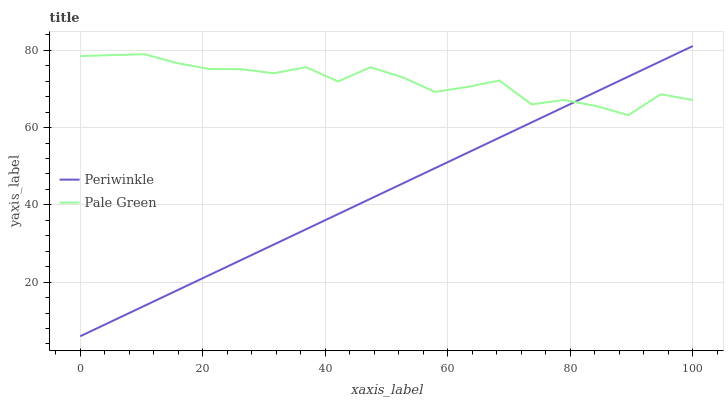Does Periwinkle have the minimum area under the curve?
Answer yes or no. Yes. Does Pale Green have the maximum area under the curve?
Answer yes or no. Yes. Does Periwinkle have the maximum area under the curve?
Answer yes or no. No. Is Periwinkle the smoothest?
Answer yes or no. Yes. Is Pale Green the roughest?
Answer yes or no. Yes. Is Periwinkle the roughest?
Answer yes or no. No. Does Periwinkle have the lowest value?
Answer yes or no. Yes. Does Periwinkle have the highest value?
Answer yes or no. Yes. Does Periwinkle intersect Pale Green?
Answer yes or no. Yes. Is Periwinkle less than Pale Green?
Answer yes or no. No. Is Periwinkle greater than Pale Green?
Answer yes or no. No. 